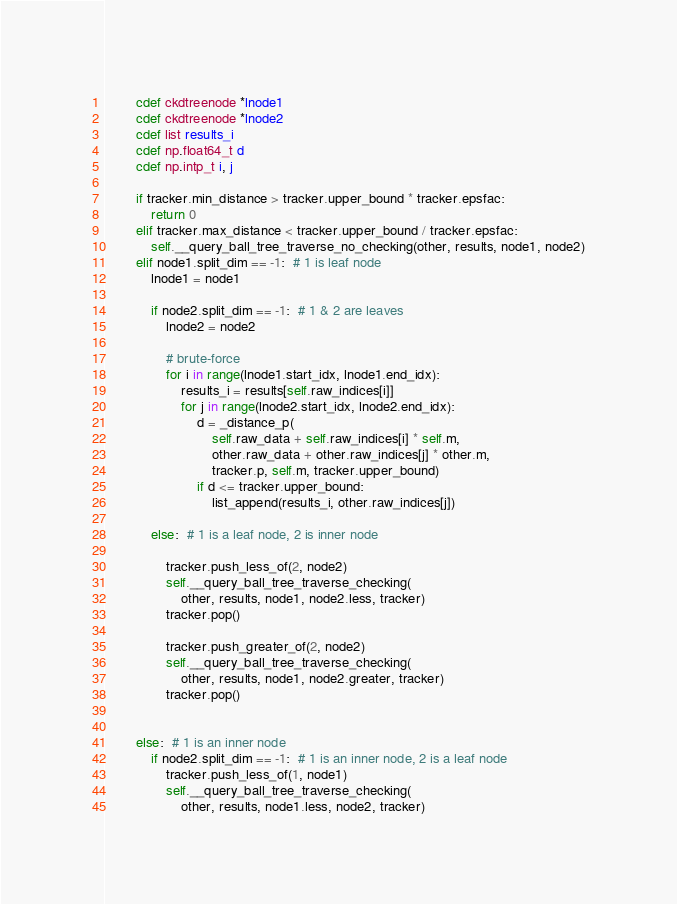Convert code to text. <code><loc_0><loc_0><loc_500><loc_500><_Cython_>        cdef ckdtreenode *lnode1
        cdef ckdtreenode *lnode2
        cdef list results_i
        cdef np.float64_t d
        cdef np.intp_t i, j

        if tracker.min_distance > tracker.upper_bound * tracker.epsfac:
            return 0
        elif tracker.max_distance < tracker.upper_bound / tracker.epsfac:
            self.__query_ball_tree_traverse_no_checking(other, results, node1, node2)
        elif node1.split_dim == -1:  # 1 is leaf node
            lnode1 = node1
            
            if node2.split_dim == -1:  # 1 & 2 are leaves
                lnode2 = node2
                
                # brute-force
                for i in range(lnode1.start_idx, lnode1.end_idx):
                    results_i = results[self.raw_indices[i]]
                    for j in range(lnode2.start_idx, lnode2.end_idx):
                        d = _distance_p(
                            self.raw_data + self.raw_indices[i] * self.m,
                            other.raw_data + other.raw_indices[j] * other.m,
                            tracker.p, self.m, tracker.upper_bound)
                        if d <= tracker.upper_bound:
                            list_append(results_i, other.raw_indices[j])
                            
            else:  # 1 is a leaf node, 2 is inner node

                tracker.push_less_of(2, node2)
                self.__query_ball_tree_traverse_checking(
                    other, results, node1, node2.less, tracker)
                tracker.pop()
                    
                tracker.push_greater_of(2, node2)
                self.__query_ball_tree_traverse_checking(
                    other, results, node1, node2.greater, tracker)
                tracker.pop()
            
                
        else:  # 1 is an inner node
            if node2.split_dim == -1:  # 1 is an inner node, 2 is a leaf node
                tracker.push_less_of(1, node1)
                self.__query_ball_tree_traverse_checking(
                    other, results, node1.less, node2, tracker)</code> 